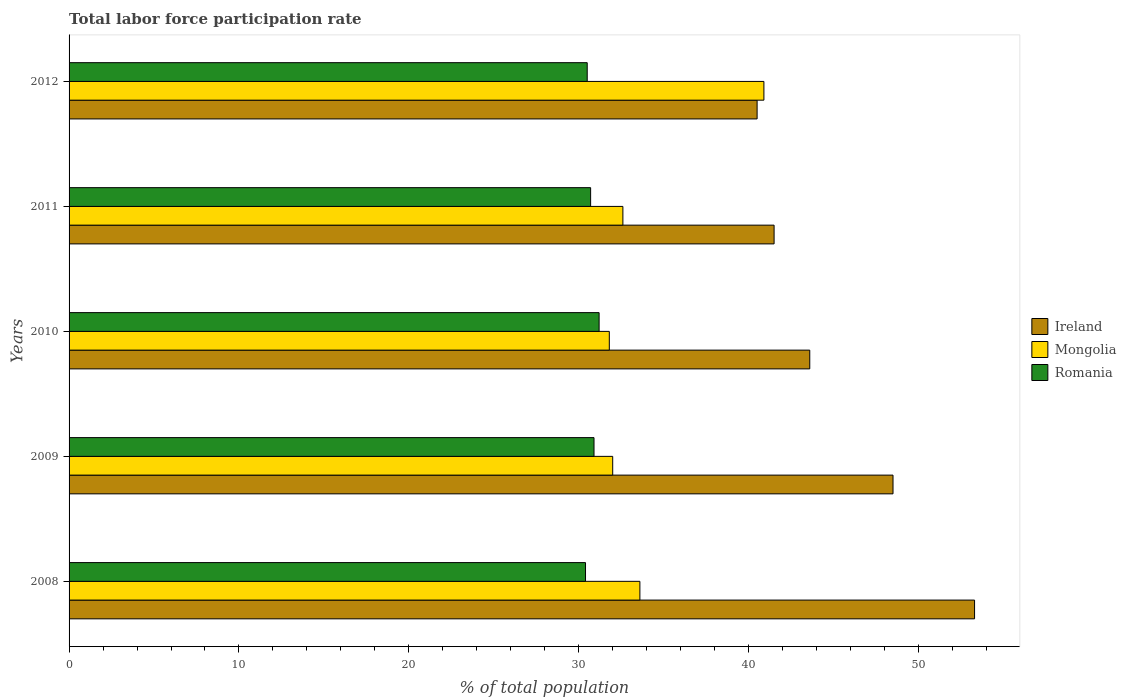How many bars are there on the 3rd tick from the top?
Make the answer very short. 3. What is the total labor force participation rate in Romania in 2010?
Give a very brief answer. 31.2. Across all years, what is the maximum total labor force participation rate in Ireland?
Provide a short and direct response. 53.3. Across all years, what is the minimum total labor force participation rate in Mongolia?
Your response must be concise. 31.8. In which year was the total labor force participation rate in Romania maximum?
Make the answer very short. 2010. What is the total total labor force participation rate in Ireland in the graph?
Give a very brief answer. 227.4. What is the difference between the total labor force participation rate in Romania in 2010 and that in 2012?
Offer a terse response. 0.7. What is the difference between the total labor force participation rate in Ireland in 2009 and the total labor force participation rate in Romania in 2008?
Make the answer very short. 18.1. What is the average total labor force participation rate in Romania per year?
Your answer should be compact. 30.74. In the year 2011, what is the difference between the total labor force participation rate in Ireland and total labor force participation rate in Romania?
Offer a terse response. 10.8. What is the ratio of the total labor force participation rate in Mongolia in 2010 to that in 2012?
Provide a succinct answer. 0.78. Is the total labor force participation rate in Ireland in 2011 less than that in 2012?
Offer a very short reply. No. Is the difference between the total labor force participation rate in Ireland in 2010 and 2012 greater than the difference between the total labor force participation rate in Romania in 2010 and 2012?
Provide a short and direct response. Yes. What is the difference between the highest and the second highest total labor force participation rate in Ireland?
Provide a short and direct response. 4.8. What is the difference between the highest and the lowest total labor force participation rate in Romania?
Your response must be concise. 0.8. Is the sum of the total labor force participation rate in Ireland in 2009 and 2010 greater than the maximum total labor force participation rate in Mongolia across all years?
Your answer should be very brief. Yes. What does the 2nd bar from the top in 2010 represents?
Ensure brevity in your answer.  Mongolia. What does the 2nd bar from the bottom in 2011 represents?
Offer a terse response. Mongolia. How many years are there in the graph?
Your answer should be compact. 5. Does the graph contain grids?
Give a very brief answer. No. What is the title of the graph?
Provide a succinct answer. Total labor force participation rate. What is the label or title of the X-axis?
Provide a succinct answer. % of total population. What is the label or title of the Y-axis?
Give a very brief answer. Years. What is the % of total population in Ireland in 2008?
Provide a short and direct response. 53.3. What is the % of total population in Mongolia in 2008?
Offer a very short reply. 33.6. What is the % of total population of Romania in 2008?
Ensure brevity in your answer.  30.4. What is the % of total population in Ireland in 2009?
Your answer should be very brief. 48.5. What is the % of total population of Romania in 2009?
Make the answer very short. 30.9. What is the % of total population in Ireland in 2010?
Offer a very short reply. 43.6. What is the % of total population in Mongolia in 2010?
Provide a short and direct response. 31.8. What is the % of total population of Romania in 2010?
Your answer should be very brief. 31.2. What is the % of total population in Ireland in 2011?
Provide a succinct answer. 41.5. What is the % of total population of Mongolia in 2011?
Provide a short and direct response. 32.6. What is the % of total population of Romania in 2011?
Make the answer very short. 30.7. What is the % of total population in Ireland in 2012?
Offer a terse response. 40.5. What is the % of total population of Mongolia in 2012?
Offer a terse response. 40.9. What is the % of total population in Romania in 2012?
Your response must be concise. 30.5. Across all years, what is the maximum % of total population of Ireland?
Make the answer very short. 53.3. Across all years, what is the maximum % of total population of Mongolia?
Ensure brevity in your answer.  40.9. Across all years, what is the maximum % of total population of Romania?
Give a very brief answer. 31.2. Across all years, what is the minimum % of total population of Ireland?
Your response must be concise. 40.5. Across all years, what is the minimum % of total population of Mongolia?
Ensure brevity in your answer.  31.8. Across all years, what is the minimum % of total population in Romania?
Keep it short and to the point. 30.4. What is the total % of total population in Ireland in the graph?
Keep it short and to the point. 227.4. What is the total % of total population of Mongolia in the graph?
Keep it short and to the point. 170.9. What is the total % of total population in Romania in the graph?
Provide a short and direct response. 153.7. What is the difference between the % of total population in Mongolia in 2008 and that in 2009?
Keep it short and to the point. 1.6. What is the difference between the % of total population of Romania in 2008 and that in 2010?
Ensure brevity in your answer.  -0.8. What is the difference between the % of total population of Mongolia in 2008 and that in 2011?
Offer a very short reply. 1. What is the difference between the % of total population in Mongolia in 2009 and that in 2010?
Your response must be concise. 0.2. What is the difference between the % of total population in Mongolia in 2009 and that in 2011?
Make the answer very short. -0.6. What is the difference between the % of total population of Romania in 2009 and that in 2011?
Ensure brevity in your answer.  0.2. What is the difference between the % of total population of Ireland in 2009 and that in 2012?
Give a very brief answer. 8. What is the difference between the % of total population in Romania in 2009 and that in 2012?
Your answer should be very brief. 0.4. What is the difference between the % of total population of Romania in 2010 and that in 2011?
Give a very brief answer. 0.5. What is the difference between the % of total population of Mongolia in 2010 and that in 2012?
Your answer should be compact. -9.1. What is the difference between the % of total population in Romania in 2010 and that in 2012?
Your response must be concise. 0.7. What is the difference between the % of total population of Ireland in 2011 and that in 2012?
Make the answer very short. 1. What is the difference between the % of total population in Ireland in 2008 and the % of total population in Mongolia in 2009?
Ensure brevity in your answer.  21.3. What is the difference between the % of total population in Ireland in 2008 and the % of total population in Romania in 2009?
Make the answer very short. 22.4. What is the difference between the % of total population of Ireland in 2008 and the % of total population of Mongolia in 2010?
Provide a succinct answer. 21.5. What is the difference between the % of total population of Ireland in 2008 and the % of total population of Romania in 2010?
Provide a short and direct response. 22.1. What is the difference between the % of total population in Ireland in 2008 and the % of total population in Mongolia in 2011?
Make the answer very short. 20.7. What is the difference between the % of total population in Ireland in 2008 and the % of total population in Romania in 2011?
Ensure brevity in your answer.  22.6. What is the difference between the % of total population in Ireland in 2008 and the % of total population in Mongolia in 2012?
Provide a succinct answer. 12.4. What is the difference between the % of total population of Ireland in 2008 and the % of total population of Romania in 2012?
Ensure brevity in your answer.  22.8. What is the difference between the % of total population in Ireland in 2009 and the % of total population in Romania in 2010?
Offer a very short reply. 17.3. What is the difference between the % of total population of Mongolia in 2009 and the % of total population of Romania in 2010?
Your answer should be compact. 0.8. What is the difference between the % of total population in Ireland in 2009 and the % of total population in Mongolia in 2011?
Provide a succinct answer. 15.9. What is the difference between the % of total population of Mongolia in 2009 and the % of total population of Romania in 2011?
Your answer should be compact. 1.3. What is the difference between the % of total population of Ireland in 2009 and the % of total population of Mongolia in 2012?
Provide a succinct answer. 7.6. What is the difference between the % of total population in Ireland in 2010 and the % of total population in Romania in 2011?
Ensure brevity in your answer.  12.9. What is the difference between the % of total population of Ireland in 2010 and the % of total population of Mongolia in 2012?
Your answer should be compact. 2.7. What is the difference between the % of total population of Ireland in 2011 and the % of total population of Mongolia in 2012?
Offer a terse response. 0.6. What is the difference between the % of total population of Ireland in 2011 and the % of total population of Romania in 2012?
Your answer should be compact. 11. What is the difference between the % of total population in Mongolia in 2011 and the % of total population in Romania in 2012?
Your response must be concise. 2.1. What is the average % of total population of Ireland per year?
Your answer should be very brief. 45.48. What is the average % of total population of Mongolia per year?
Ensure brevity in your answer.  34.18. What is the average % of total population of Romania per year?
Make the answer very short. 30.74. In the year 2008, what is the difference between the % of total population in Ireland and % of total population in Romania?
Your answer should be very brief. 22.9. In the year 2008, what is the difference between the % of total population of Mongolia and % of total population of Romania?
Your response must be concise. 3.2. In the year 2009, what is the difference between the % of total population in Ireland and % of total population in Romania?
Ensure brevity in your answer.  17.6. In the year 2010, what is the difference between the % of total population in Ireland and % of total population in Mongolia?
Provide a succinct answer. 11.8. In the year 2011, what is the difference between the % of total population in Ireland and % of total population in Mongolia?
Your answer should be compact. 8.9. In the year 2011, what is the difference between the % of total population of Ireland and % of total population of Romania?
Your answer should be very brief. 10.8. In the year 2012, what is the difference between the % of total population of Ireland and % of total population of Mongolia?
Offer a very short reply. -0.4. In the year 2012, what is the difference between the % of total population in Ireland and % of total population in Romania?
Offer a very short reply. 10. In the year 2012, what is the difference between the % of total population in Mongolia and % of total population in Romania?
Your answer should be very brief. 10.4. What is the ratio of the % of total population of Ireland in 2008 to that in 2009?
Provide a short and direct response. 1.1. What is the ratio of the % of total population in Mongolia in 2008 to that in 2009?
Your response must be concise. 1.05. What is the ratio of the % of total population of Romania in 2008 to that in 2009?
Offer a terse response. 0.98. What is the ratio of the % of total population in Ireland in 2008 to that in 2010?
Your answer should be very brief. 1.22. What is the ratio of the % of total population of Mongolia in 2008 to that in 2010?
Make the answer very short. 1.06. What is the ratio of the % of total population of Romania in 2008 to that in 2010?
Offer a very short reply. 0.97. What is the ratio of the % of total population of Ireland in 2008 to that in 2011?
Give a very brief answer. 1.28. What is the ratio of the % of total population of Mongolia in 2008 to that in 2011?
Keep it short and to the point. 1.03. What is the ratio of the % of total population of Romania in 2008 to that in 2011?
Provide a succinct answer. 0.99. What is the ratio of the % of total population in Ireland in 2008 to that in 2012?
Offer a terse response. 1.32. What is the ratio of the % of total population in Mongolia in 2008 to that in 2012?
Your answer should be very brief. 0.82. What is the ratio of the % of total population of Ireland in 2009 to that in 2010?
Keep it short and to the point. 1.11. What is the ratio of the % of total population in Ireland in 2009 to that in 2011?
Provide a short and direct response. 1.17. What is the ratio of the % of total population in Mongolia in 2009 to that in 2011?
Ensure brevity in your answer.  0.98. What is the ratio of the % of total population of Romania in 2009 to that in 2011?
Offer a terse response. 1.01. What is the ratio of the % of total population of Ireland in 2009 to that in 2012?
Your answer should be very brief. 1.2. What is the ratio of the % of total population in Mongolia in 2009 to that in 2012?
Give a very brief answer. 0.78. What is the ratio of the % of total population in Romania in 2009 to that in 2012?
Offer a terse response. 1.01. What is the ratio of the % of total population in Ireland in 2010 to that in 2011?
Give a very brief answer. 1.05. What is the ratio of the % of total population in Mongolia in 2010 to that in 2011?
Provide a short and direct response. 0.98. What is the ratio of the % of total population in Romania in 2010 to that in 2011?
Your response must be concise. 1.02. What is the ratio of the % of total population of Ireland in 2010 to that in 2012?
Your answer should be compact. 1.08. What is the ratio of the % of total population in Mongolia in 2010 to that in 2012?
Keep it short and to the point. 0.78. What is the ratio of the % of total population in Romania in 2010 to that in 2012?
Provide a short and direct response. 1.02. What is the ratio of the % of total population of Ireland in 2011 to that in 2012?
Your answer should be very brief. 1.02. What is the ratio of the % of total population in Mongolia in 2011 to that in 2012?
Offer a terse response. 0.8. What is the ratio of the % of total population of Romania in 2011 to that in 2012?
Your answer should be compact. 1.01. What is the difference between the highest and the second highest % of total population in Romania?
Offer a very short reply. 0.3. 